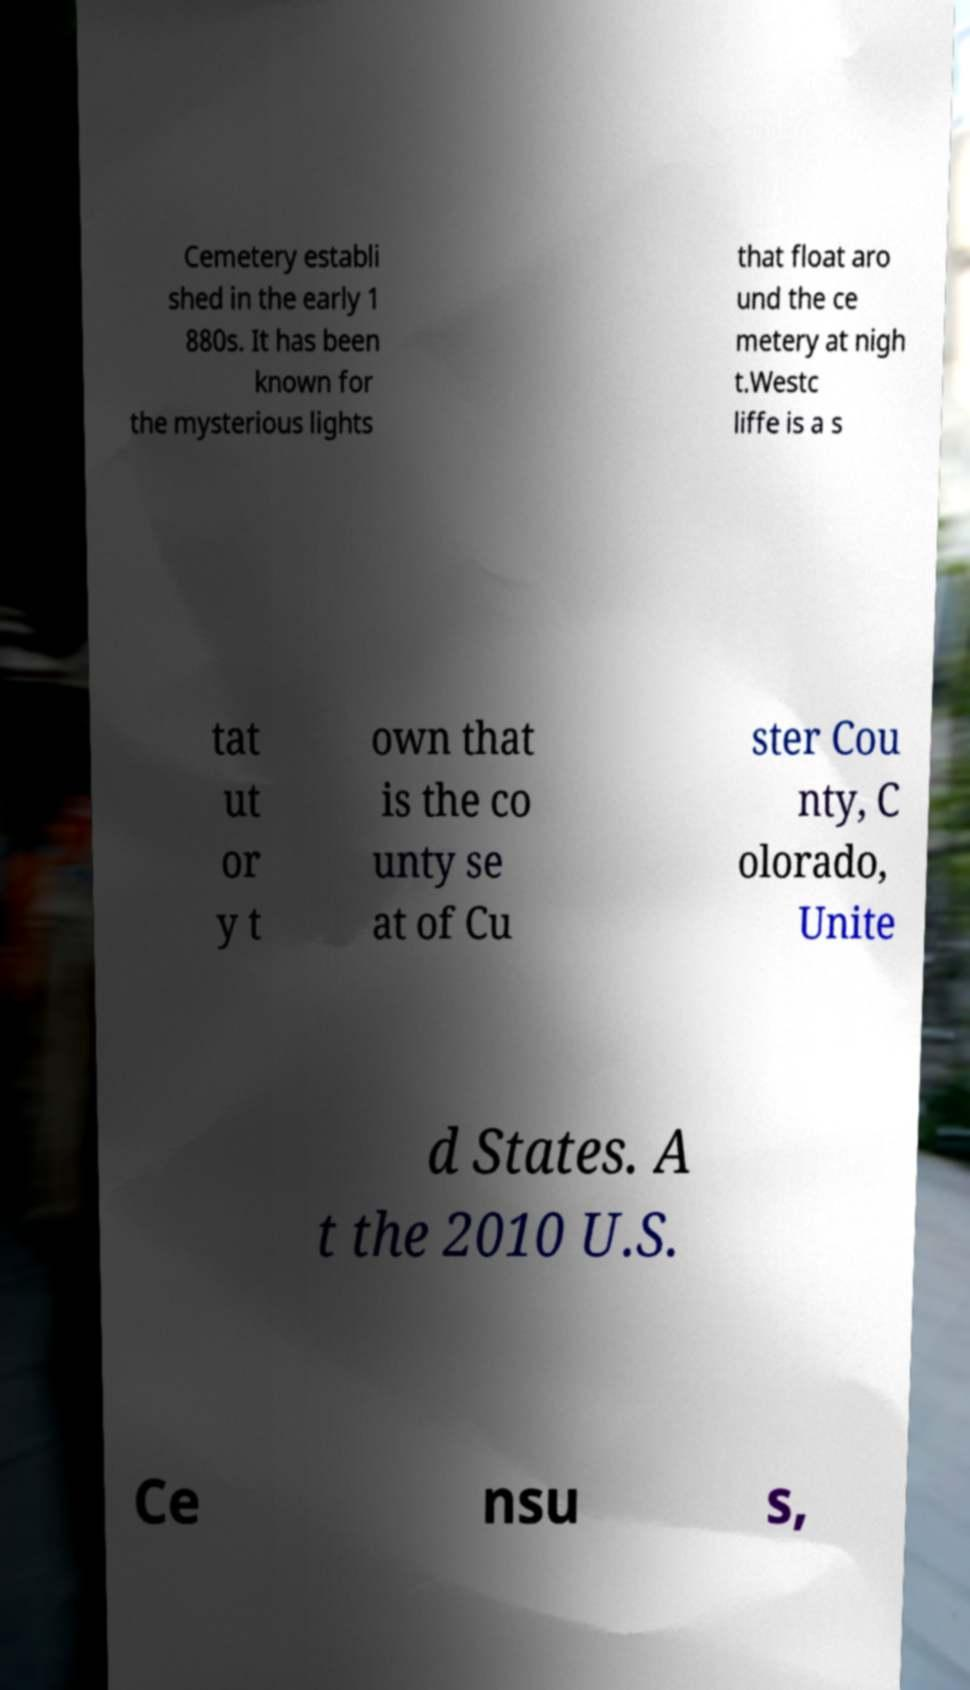Please read and relay the text visible in this image. What does it say? Cemetery establi shed in the early 1 880s. It has been known for the mysterious lights that float aro und the ce metery at nigh t.Westc liffe is a s tat ut or y t own that is the co unty se at of Cu ster Cou nty, C olorado, Unite d States. A t the 2010 U.S. Ce nsu s, 